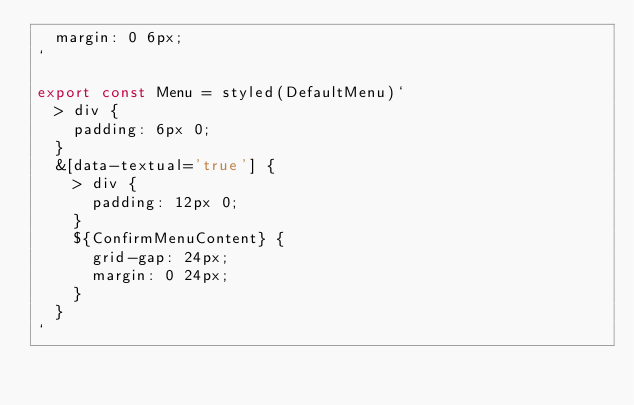<code> <loc_0><loc_0><loc_500><loc_500><_TypeScript_>  margin: 0 6px;
`

export const Menu = styled(DefaultMenu)`
  > div {
    padding: 6px 0;
  }
  &[data-textual='true'] {
    > div {
      padding: 12px 0;
    }
    ${ConfirmMenuContent} {
      grid-gap: 24px;
      margin: 0 24px;
    }
  }
`
</code> 